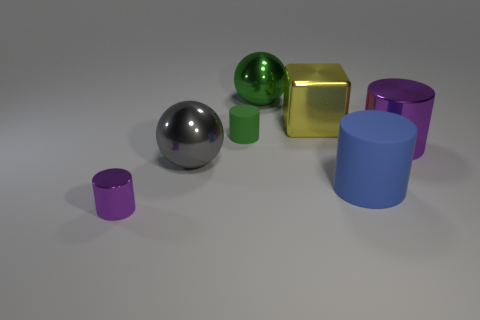What can you infer about the lighting in this scene? The lighting in this scene seems to be coming from the upper left side, as evidenced by the positioning of the shadows. All objects have shadows that fall towards the bottom right, suggesting a single, consistent light source, which could be either natural or artificial. Does the lighting affect the color of the objects? Yes, the intensity and direction of the light can impact how the colors of the objects are perceived. In this scene, the light may enhance the vividness of the colors and the metallic sheen, while the shadows help define the shapes of the objects more clearly. 